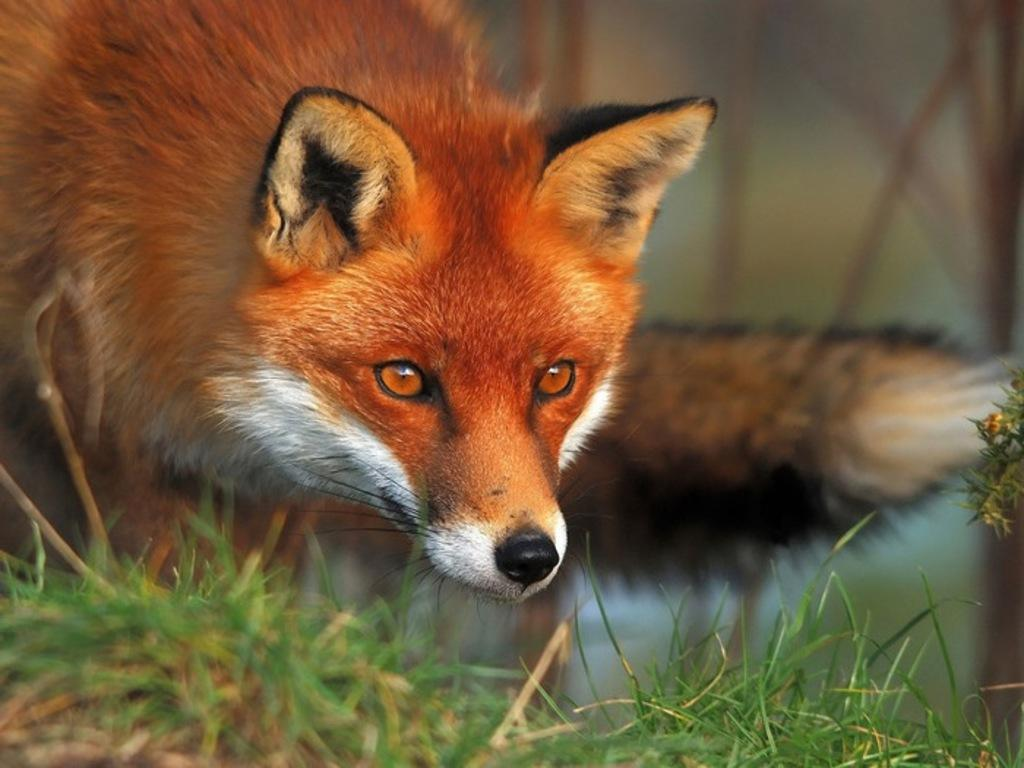What animal can be seen in the image? There is a fox in the image. Where is the fox located in the image? The fox is present on the ground. What type of surface is the fox standing on? The ground is covered with grass. What type of pets are playing volleyball in the image? There are no pets or volleyball present in the image; it features a fox standing on grass. 